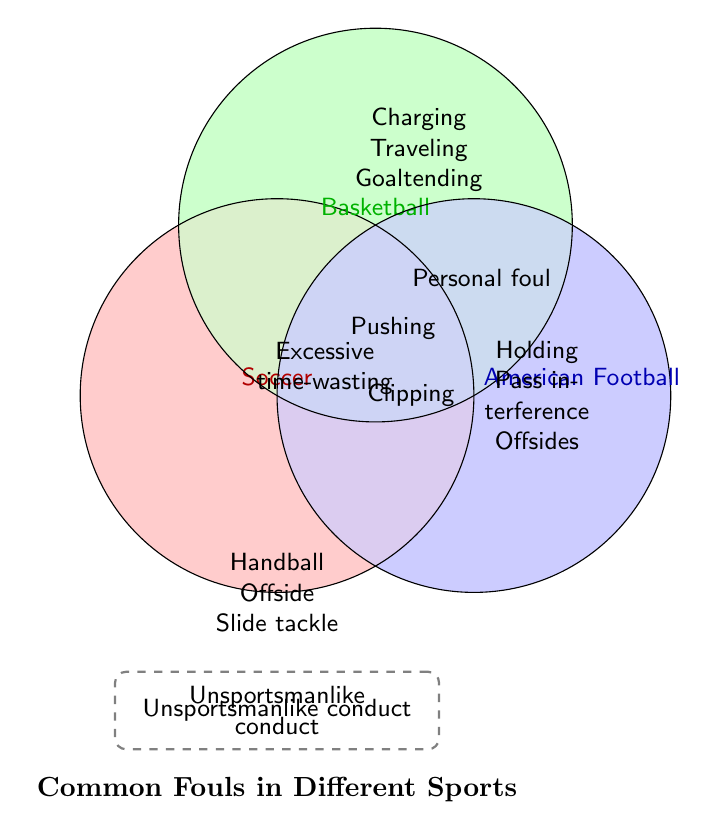What's the title of the figure? The title of the figure is displayed prominently near the bottom.
Answer: Common Fouls in Different Sports Which foul is common in all three sports: Soccer, Basketball, and American Football? Looking where all three circles intersect reveals the answer.
Answer: Excessive time-wasting Which sport has fouls like 'Handball', 'Offside', and 'Slide tackle'? By checking which circle contains these specific fouls.
Answer: Soccer How many fouls are shared between Basketball and American Football but not Soccer? Find the intersection between Basketball and American Football only.
Answer: One (Personal foul) What foul is represented outside the circles but still related to all sports? Check non-overlapping area outside the circles but within the larger boundary.
Answer: Unsportsmanlike conduct Name a foul shared only between Soccer and American Football. Look at the intersection of Soccer and American Football excluding Basketball.
Answer: Clipping Which sport has the most unique fouls? Count and compare the unique fouls listed in each circle separately.
Answer: Basketball (3 unique fouls) Is 'Charging' a foul in Soccer? Verify if 'Charging' appears in the Soccer circle.
Answer: No Which fouls are common between Soccer and Basketball? Check the intersection area between Soccer and Basketball circles.
Answer: Pushing 